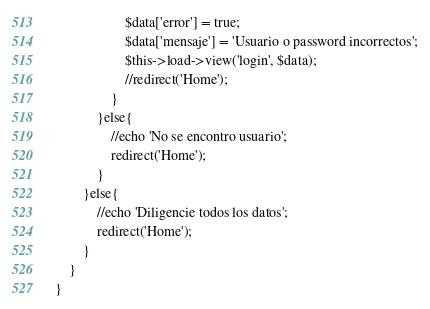Convert code to text. <code><loc_0><loc_0><loc_500><loc_500><_PHP_>					$data['error'] = true;
					$data['mensaje'] = 'Usuario o password incorrectos';
					$this->load->view('login', $data);
					//redirect('Home');
				}
			}else{
				//echo 'No se encontro usuario';
				redirect('Home');
			}
		}else{
			//echo 'Diligencie todos los datos';
			redirect('Home');
		}					
	}
}
</code> 